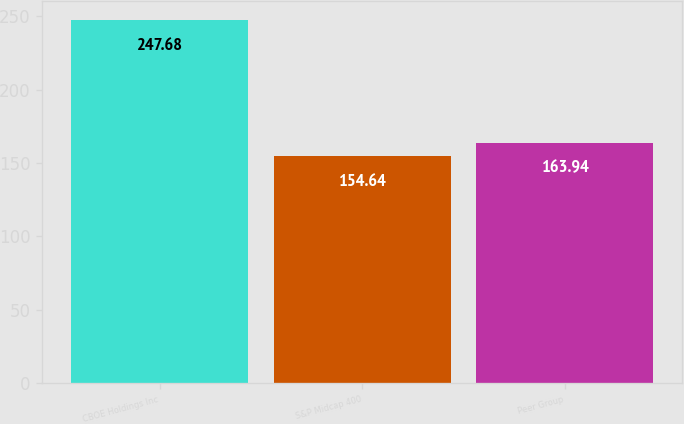Convert chart. <chart><loc_0><loc_0><loc_500><loc_500><bar_chart><fcel>CBOE Holdings Inc<fcel>S&P Midcap 400<fcel>Peer Group<nl><fcel>247.68<fcel>154.64<fcel>163.94<nl></chart> 